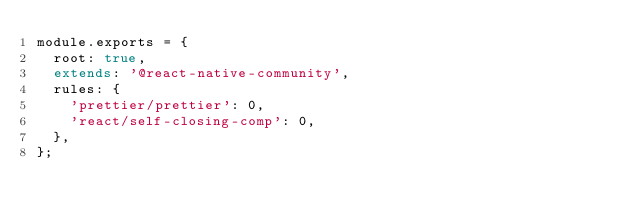<code> <loc_0><loc_0><loc_500><loc_500><_JavaScript_>module.exports = {
  root: true,
  extends: '@react-native-community',
  rules: {
    'prettier/prettier': 0,
    'react/self-closing-comp': 0,
  },
};
</code> 